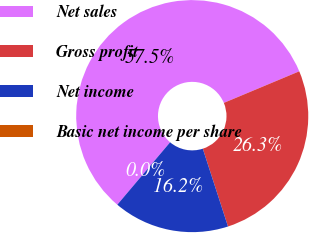Convert chart to OTSL. <chart><loc_0><loc_0><loc_500><loc_500><pie_chart><fcel>Net sales<fcel>Gross profit<fcel>Net income<fcel>Basic net income per share<nl><fcel>57.52%<fcel>26.32%<fcel>16.16%<fcel>0.0%<nl></chart> 